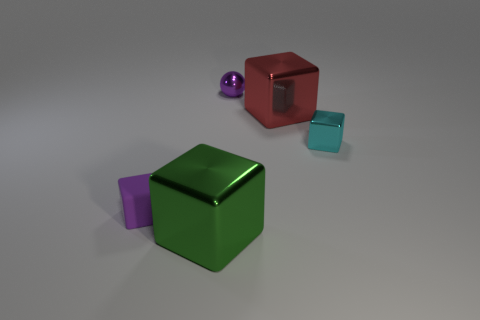Is there a big cyan shiny sphere?
Your answer should be compact. No. The tiny thing on the left side of the big object that is in front of the small cyan thing is what color?
Give a very brief answer. Purple. What number of other objects are there of the same color as the tiny shiny cube?
Keep it short and to the point. 0. How many objects are red matte blocks or small blocks that are on the right side of the metal ball?
Provide a short and direct response. 1. The tiny cube right of the green shiny object is what color?
Offer a very short reply. Cyan. What shape is the purple matte thing?
Provide a short and direct response. Cube. What is the material of the tiny block that is to the left of the large cube on the left side of the metallic ball?
Your answer should be very brief. Rubber. How many other objects are there of the same material as the purple block?
Your answer should be compact. 0. There is a ball that is the same size as the cyan block; what is it made of?
Your response must be concise. Metal. Is the number of purple matte things in front of the cyan cube greater than the number of purple blocks on the left side of the tiny rubber block?
Make the answer very short. Yes. 